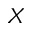<formula> <loc_0><loc_0><loc_500><loc_500>X</formula> 